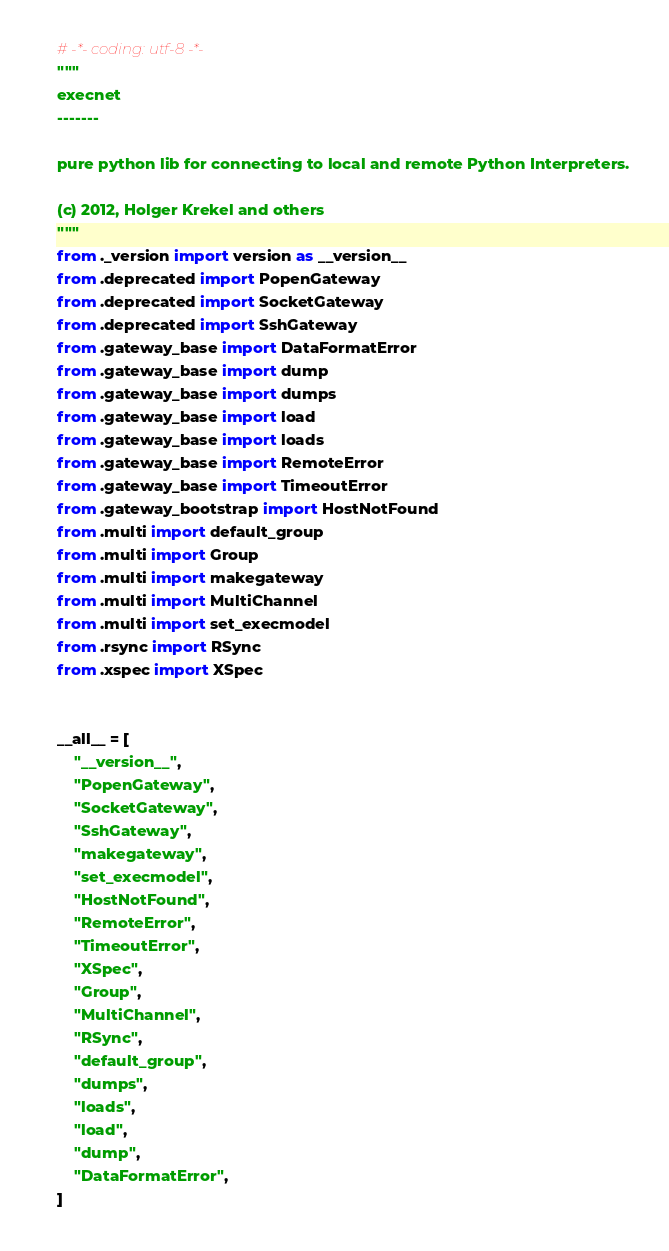Convert code to text. <code><loc_0><loc_0><loc_500><loc_500><_Python_># -*- coding: utf-8 -*-
"""
execnet
-------

pure python lib for connecting to local and remote Python Interpreters.

(c) 2012, Holger Krekel and others
"""
from ._version import version as __version__
from .deprecated import PopenGateway
from .deprecated import SocketGateway
from .deprecated import SshGateway
from .gateway_base import DataFormatError
from .gateway_base import dump
from .gateway_base import dumps
from .gateway_base import load
from .gateway_base import loads
from .gateway_base import RemoteError
from .gateway_base import TimeoutError
from .gateway_bootstrap import HostNotFound
from .multi import default_group
from .multi import Group
from .multi import makegateway
from .multi import MultiChannel
from .multi import set_execmodel
from .rsync import RSync
from .xspec import XSpec


__all__ = [
    "__version__",
    "PopenGateway",
    "SocketGateway",
    "SshGateway",
    "makegateway",
    "set_execmodel",
    "HostNotFound",
    "RemoteError",
    "TimeoutError",
    "XSpec",
    "Group",
    "MultiChannel",
    "RSync",
    "default_group",
    "dumps",
    "loads",
    "load",
    "dump",
    "DataFormatError",
]
</code> 